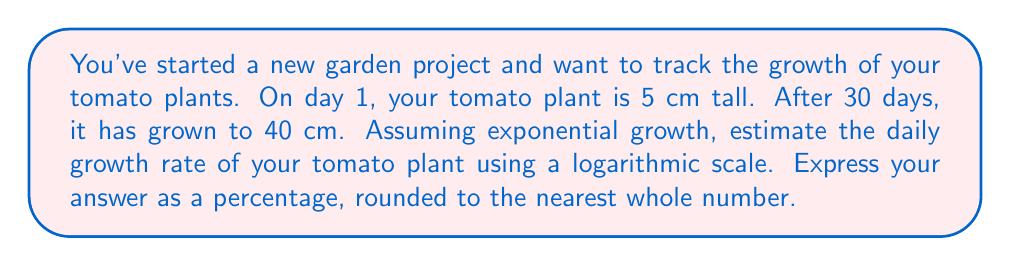Help me with this question. Let's approach this step-by-step using the exponential growth formula and logarithms:

1) The exponential growth formula is:
   $A = P(1 + r)^t$
   Where A is the final amount, P is the initial amount, r is the daily growth rate, and t is the number of days.

2) Plugging in our values:
   $40 = 5(1 + r)^{30}$

3) Divide both sides by 5:
   $8 = (1 + r)^{30}$

4) Now, let's take the natural logarithm of both sides:
   $\ln(8) = \ln((1 + r)^{30})$

5) Using the logarithm property $\ln(a^b) = b\ln(a)$:
   $\ln(8) = 30\ln(1 + r)$

6) Divide both sides by 30:
   $\frac{\ln(8)}{30} = \ln(1 + r)$

7) Now, let's exponentiate both sides:
   $e^{\frac{\ln(8)}{30}} = e^{\ln(1 + r)} = 1 + r$

8) Subtract 1 from both sides:
   $e^{\frac{\ln(8)}{30}} - 1 = r$

9) Calculate:
   $r \approx 0.0699 = 6.99\%$

10) Rounding to the nearest whole number:
    $r \approx 7\%$
Answer: 7% 